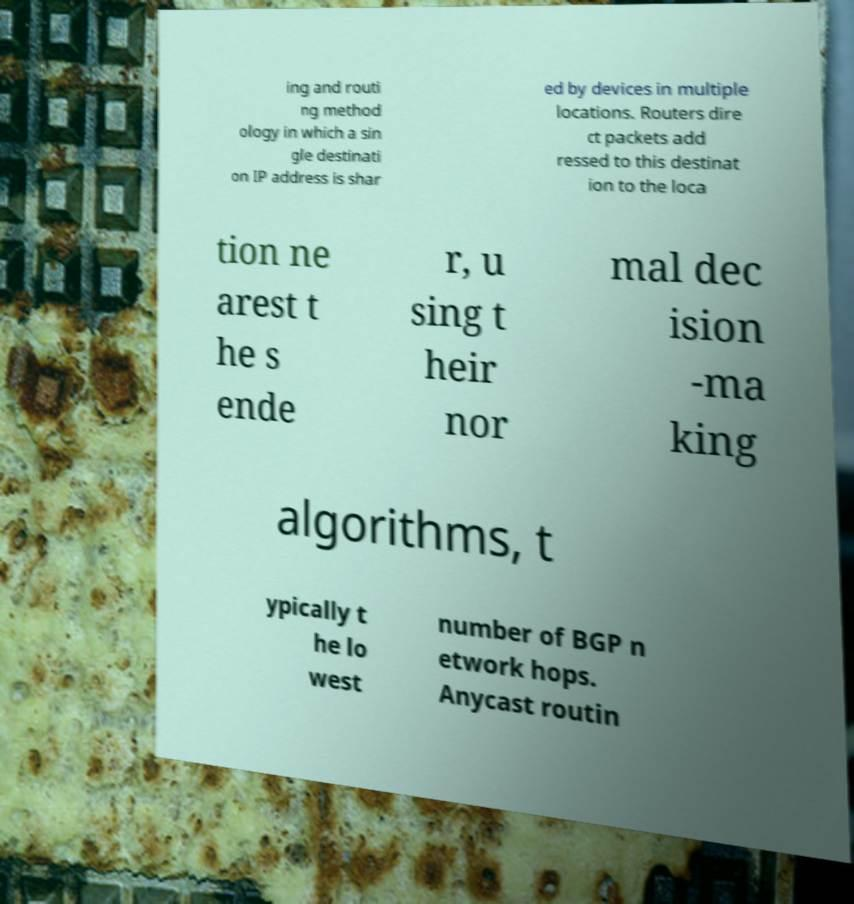There's text embedded in this image that I need extracted. Can you transcribe it verbatim? ing and routi ng method ology in which a sin gle destinati on IP address is shar ed by devices in multiple locations. Routers dire ct packets add ressed to this destinat ion to the loca tion ne arest t he s ende r, u sing t heir nor mal dec ision -ma king algorithms, t ypically t he lo west number of BGP n etwork hops. Anycast routin 